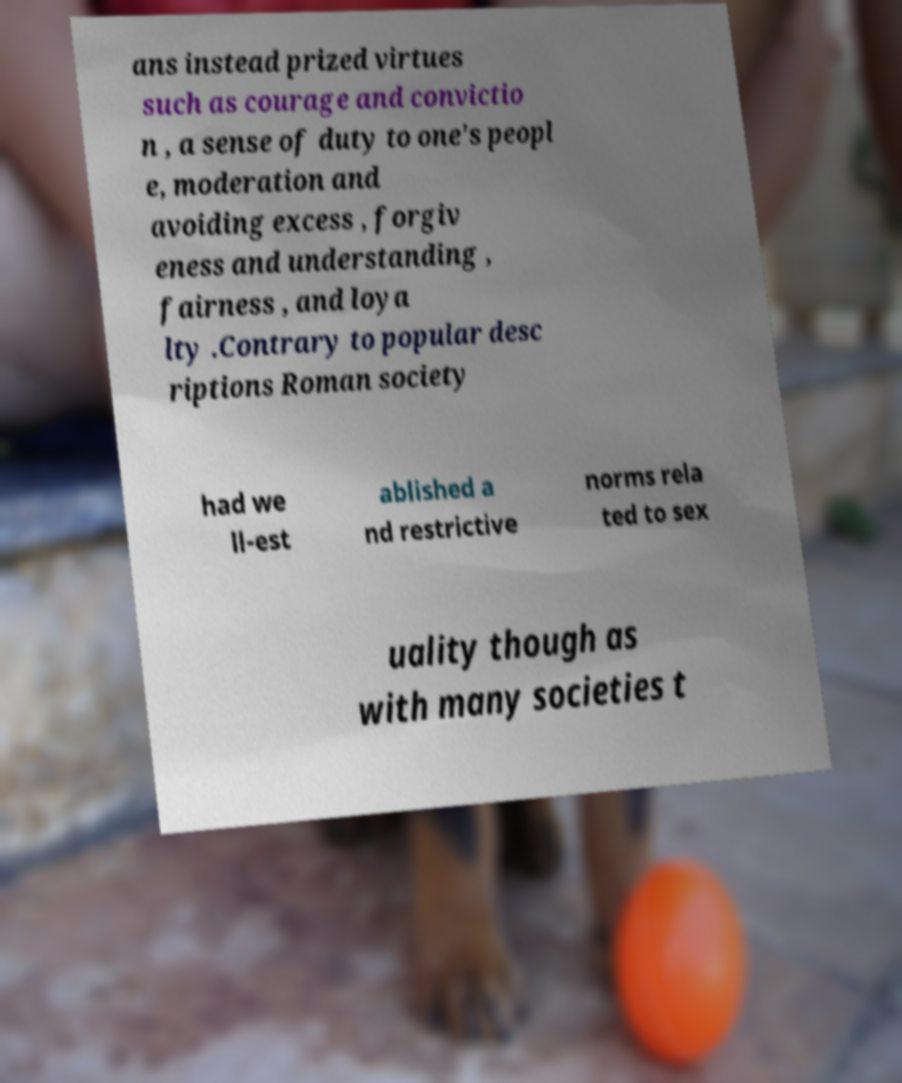Could you extract and type out the text from this image? ans instead prized virtues such as courage and convictio n , a sense of duty to one's peopl e, moderation and avoiding excess , forgiv eness and understanding , fairness , and loya lty .Contrary to popular desc riptions Roman society had we ll-est ablished a nd restrictive norms rela ted to sex uality though as with many societies t 